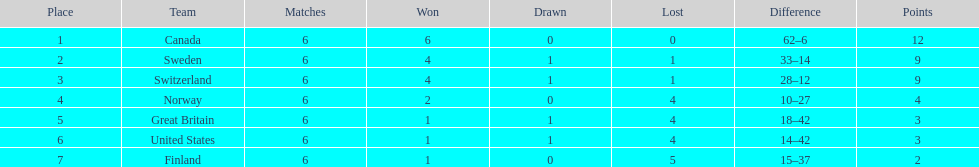Which country's team ended up in the last spot during the 1951 world ice hockey championships? Finland. 